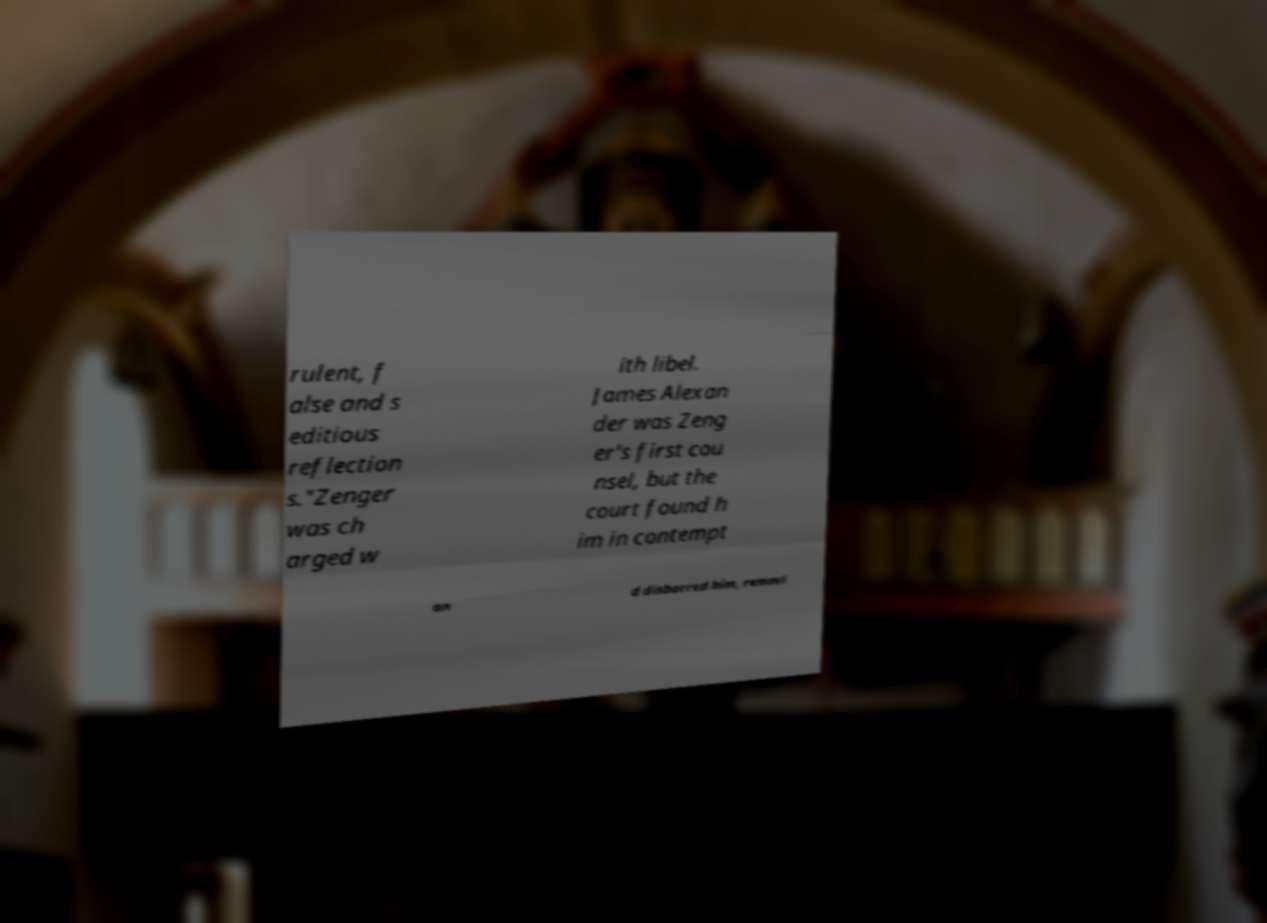For documentation purposes, I need the text within this image transcribed. Could you provide that? rulent, f alse and s editious reflection s."Zenger was ch arged w ith libel. James Alexan der was Zeng er's first cou nsel, but the court found h im in contempt an d disbarred him, removi 